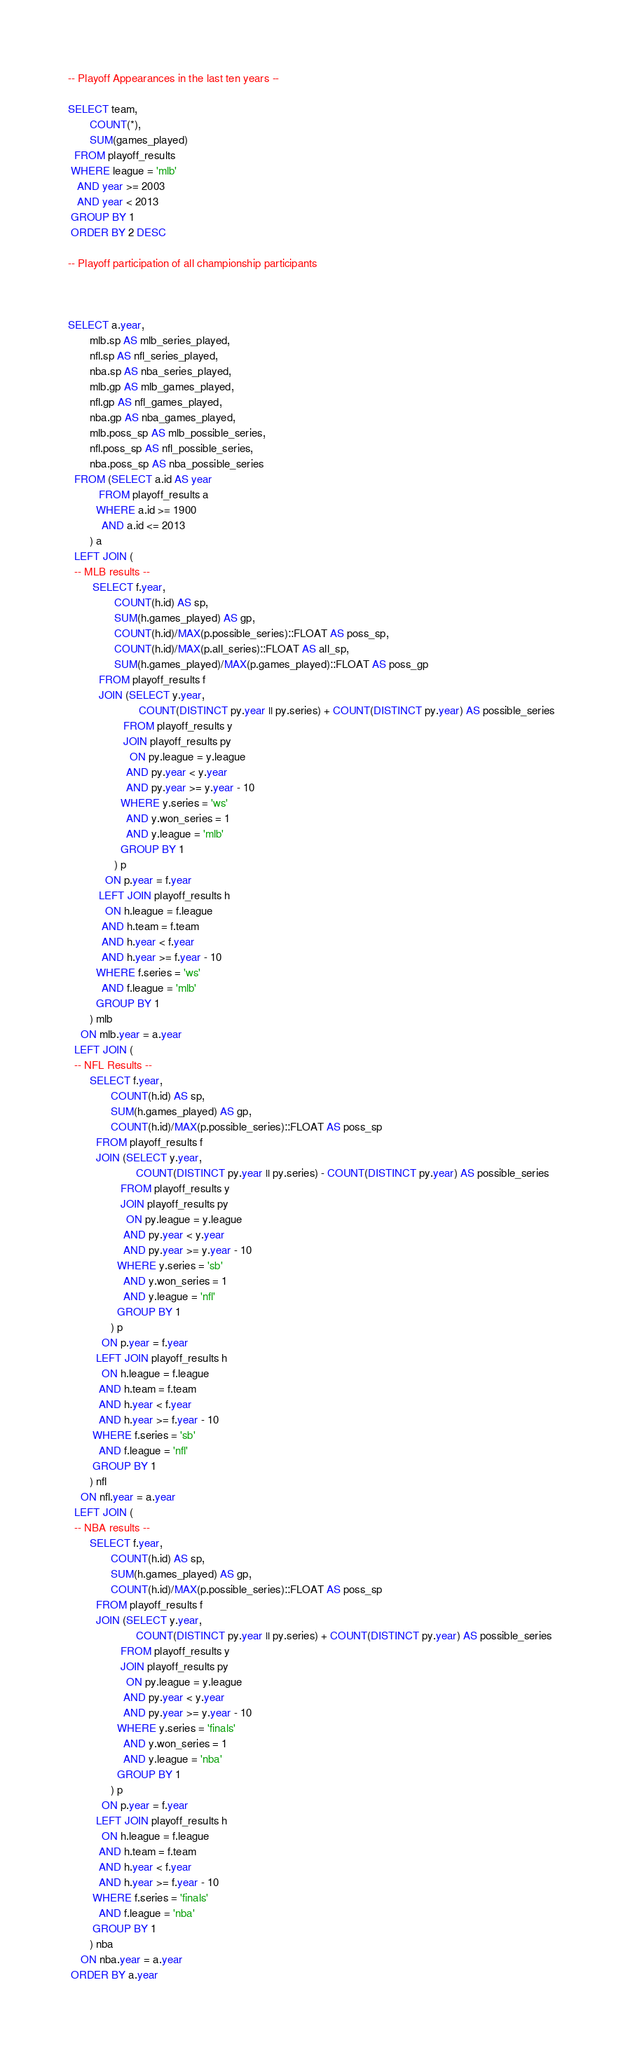Convert code to text. <code><loc_0><loc_0><loc_500><loc_500><_SQL_>-- Playoff Appearances in the last ten years --

SELECT team,
       COUNT(*),
       SUM(games_played)
  FROM playoff_results
 WHERE league = 'mlb'
   AND year >= 2003
   AND year < 2013
 GROUP BY 1
 ORDER BY 2 DESC
 
-- Playoff participation of all championship participants  



SELECT a.year,
       mlb.sp AS mlb_series_played,
       nfl.sp AS nfl_series_played,
       nba.sp AS nba_series_played,
       mlb.gp AS mlb_games_played,
       nfl.gp AS nfl_games_played,
       nba.gp AS nba_games_played,
       mlb.poss_sp AS mlb_possible_series,
       nfl.poss_sp AS nfl_possible_series,
       nba.poss_sp AS nba_possible_series
  FROM (SELECT a.id AS year
          FROM playoff_results a
         WHERE a.id >= 1900
           AND a.id <= 2013
       ) a
  LEFT JOIN (
  -- MLB results --  
        SELECT f.year,
               COUNT(h.id) AS sp,
               SUM(h.games_played) AS gp,
               COUNT(h.id)/MAX(p.possible_series)::FLOAT AS poss_sp,
               COUNT(h.id)/MAX(p.all_series)::FLOAT AS all_sp,
               SUM(h.games_played)/MAX(p.games_played)::FLOAT AS poss_gp
          FROM playoff_results f
          JOIN (SELECT y.year,
                       COUNT(DISTINCT py.year || py.series) + COUNT(DISTINCT py.year) AS possible_series
                  FROM playoff_results y
                  JOIN playoff_results py
                    ON py.league = y.league
                   AND py.year < y.year
                   AND py.year >= y.year - 10
                 WHERE y.series = 'ws'
                   AND y.won_series = 1
                   AND y.league = 'mlb'
                 GROUP BY 1
               ) p
            ON p.year = f.year
          LEFT JOIN playoff_results h
            ON h.league = f.league 
           AND h.team = f.team
           AND h.year < f.year
           AND h.year >= f.year - 10
         WHERE f.series = 'ws'
           AND f.league = 'mlb'
         GROUP BY 1
       ) mlb
    ON mlb.year = a.year
  LEFT JOIN (
  -- NFL Results -- 
       SELECT f.year,
              COUNT(h.id) AS sp,
              SUM(h.games_played) AS gp,
              COUNT(h.id)/MAX(p.possible_series)::FLOAT AS poss_sp
         FROM playoff_results f
         JOIN (SELECT y.year,
                      COUNT(DISTINCT py.year || py.series) - COUNT(DISTINCT py.year) AS possible_series
                 FROM playoff_results y
                 JOIN playoff_results py
                   ON py.league = y.league
                  AND py.year < y.year
                  AND py.year >= y.year - 10
                WHERE y.series = 'sb'
                  AND y.won_series = 1
                  AND y.league = 'nfl'
                GROUP BY 1
              ) p
           ON p.year = f.year
         LEFT JOIN playoff_results h
           ON h.league = f.league 
          AND h.team = f.team
          AND h.year < f.year
          AND h.year >= f.year - 10
        WHERE f.series = 'sb'
          AND f.league = 'nfl'
        GROUP BY 1
       ) nfl
    ON nfl.year = a.year
  LEFT JOIN (
  -- NBA results --
       SELECT f.year,
              COUNT(h.id) AS sp,
              SUM(h.games_played) AS gp,
              COUNT(h.id)/MAX(p.possible_series)::FLOAT AS poss_sp
         FROM playoff_results f
         JOIN (SELECT y.year,
                      COUNT(DISTINCT py.year || py.series) + COUNT(DISTINCT py.year) AS possible_series
                 FROM playoff_results y
                 JOIN playoff_results py
                   ON py.league = y.league
                  AND py.year < y.year
                  AND py.year >= y.year - 10
                WHERE y.series = 'finals'
                  AND y.won_series = 1
                  AND y.league = 'nba'
                GROUP BY 1
              ) p
           ON p.year = f.year
         LEFT JOIN playoff_results h
           ON h.league = f.league 
          AND h.team = f.team
          AND h.year < f.year
          AND h.year >= f.year - 10
        WHERE f.series = 'finals'
          AND f.league = 'nba'
        GROUP BY 1
       ) nba
    ON nba.year = a.year 
 ORDER BY a.year
</code> 